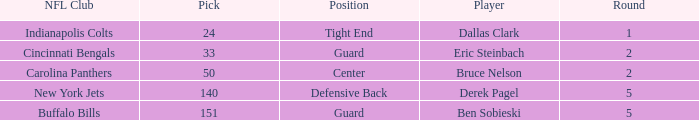What was the latest round that Derek Pagel was selected with a pick higher than 50? 5.0. 